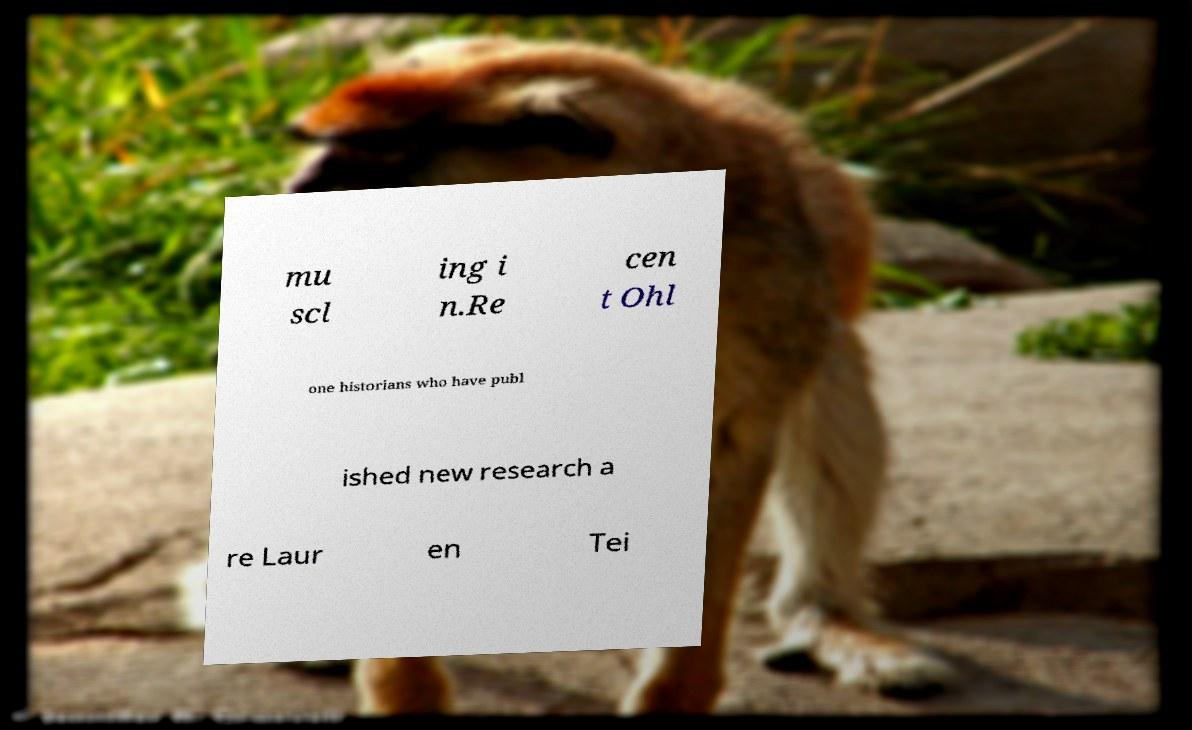For documentation purposes, I need the text within this image transcribed. Could you provide that? mu scl ing i n.Re cen t Ohl one historians who have publ ished new research a re Laur en Tei 